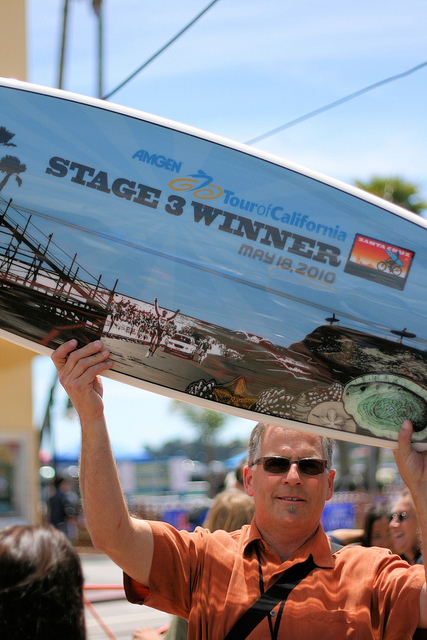Read all the text in this image. STAGE AMGEN WINNER may 3 California of Tour 2010 18 